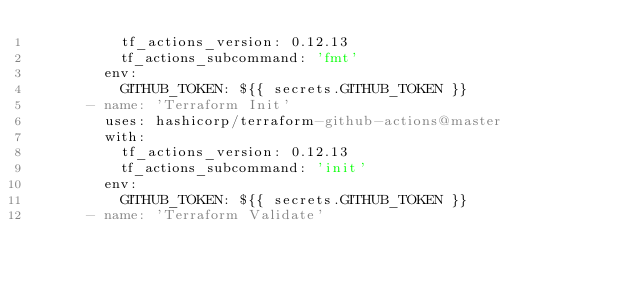<code> <loc_0><loc_0><loc_500><loc_500><_YAML_>          tf_actions_version: 0.12.13
          tf_actions_subcommand: 'fmt'
        env:
          GITHUB_TOKEN: ${{ secrets.GITHUB_TOKEN }}
      - name: 'Terraform Init'
        uses: hashicorp/terraform-github-actions@master
        with:
          tf_actions_version: 0.12.13
          tf_actions_subcommand: 'init'
        env:
          GITHUB_TOKEN: ${{ secrets.GITHUB_TOKEN }}
      - name: 'Terraform Validate'</code> 